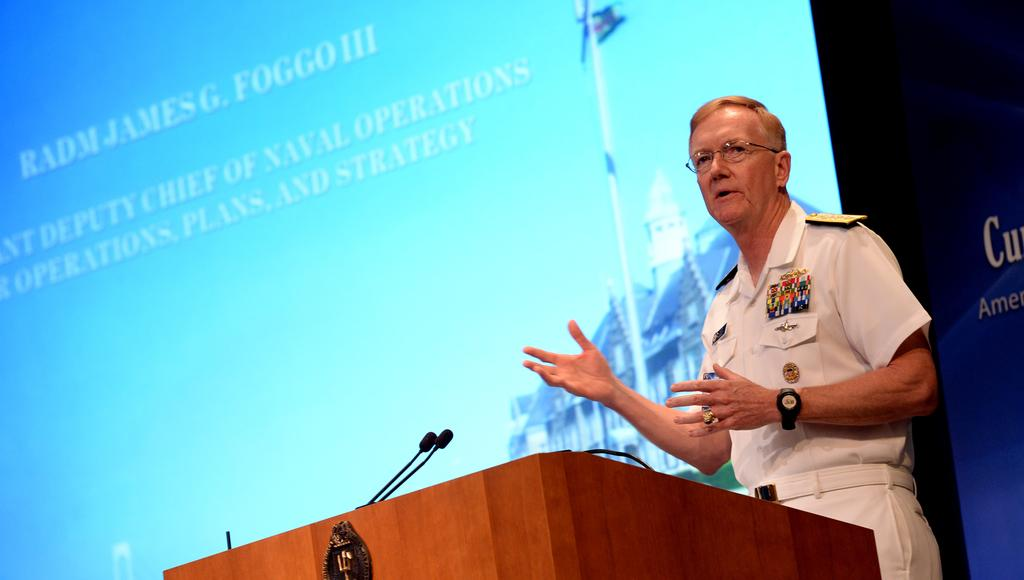What is the main object in the image? There is a podium in the image. Where is the person located in relation to the podium? The person is present on the right side of the image. What is behind the person? There is a screen behind the person. What can be seen at the bottom of the image? There are microphones at the bottom of the image. What type of eggnog is being served at the station in the image? There is no eggnog or station present in the image. What type of doctor is standing near the podium in the image? There is no doctor present in the image. 